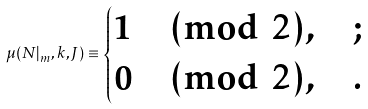Convert formula to latex. <formula><loc_0><loc_0><loc_500><loc_500>\mu ( N | _ { m } , k , J ) \equiv \begin{cases} 1 \pmod { 2 } , & ; \\ 0 \pmod { 2 } , & . \\ \end{cases}</formula> 